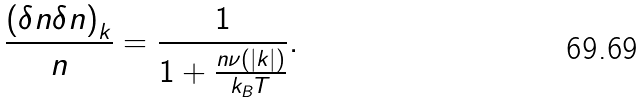<formula> <loc_0><loc_0><loc_500><loc_500>\frac { \left ( \delta n \delta n \right ) _ { k } } { n } = \frac { 1 } { 1 + \frac { n \nu ( \left | k \right | ) } { k _ { B } T } } .</formula> 